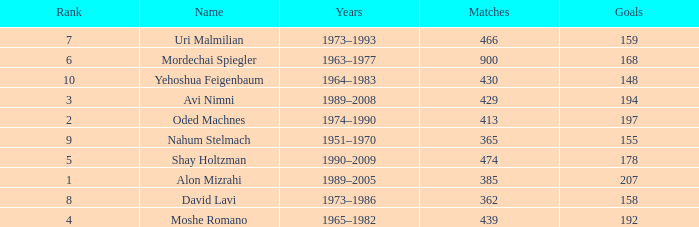What is the Rank of the player with 362 Matches? 8.0. 